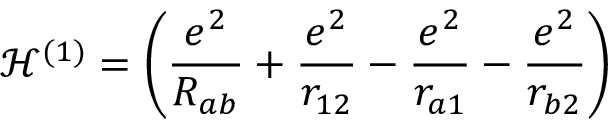Convert formula to latex. <formula><loc_0><loc_0><loc_500><loc_500>{ \mathcal { H } } ^ { ( 1 ) } = \left ( { \frac { e ^ { 2 } } { R _ { a b } } } + { \frac { e ^ { 2 } } { r _ { 1 2 } } } - { \frac { e ^ { 2 } } { r _ { a 1 } } } - { \frac { e ^ { 2 } } { r _ { b 2 } } } \right )</formula> 